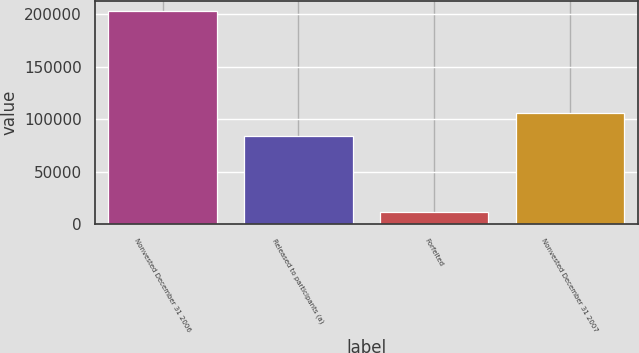<chart> <loc_0><loc_0><loc_500><loc_500><bar_chart><fcel>Nonvested December 31 2006<fcel>Released to participants (a)<fcel>Forfeited<fcel>Nonvested December 31 2007<nl><fcel>202885<fcel>84418<fcel>12328<fcel>106139<nl></chart> 